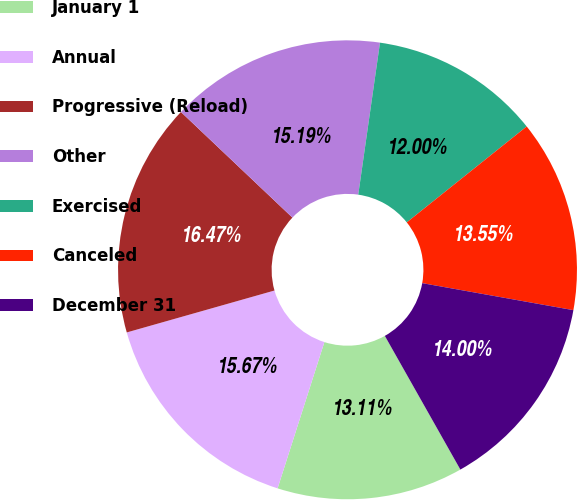Convert chart. <chart><loc_0><loc_0><loc_500><loc_500><pie_chart><fcel>January 1<fcel>Annual<fcel>Progressive (Reload)<fcel>Other<fcel>Exercised<fcel>Canceled<fcel>December 31<nl><fcel>13.11%<fcel>15.67%<fcel>16.47%<fcel>15.19%<fcel>12.0%<fcel>13.55%<fcel>14.0%<nl></chart> 